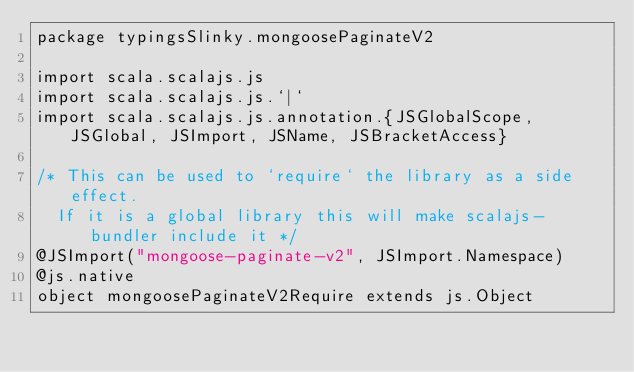<code> <loc_0><loc_0><loc_500><loc_500><_Scala_>package typingsSlinky.mongoosePaginateV2

import scala.scalajs.js
import scala.scalajs.js.`|`
import scala.scalajs.js.annotation.{JSGlobalScope, JSGlobal, JSImport, JSName, JSBracketAccess}

/* This can be used to `require` the library as a side effect.
  If it is a global library this will make scalajs-bundler include it */
@JSImport("mongoose-paginate-v2", JSImport.Namespace)
@js.native
object mongoosePaginateV2Require extends js.Object
</code> 